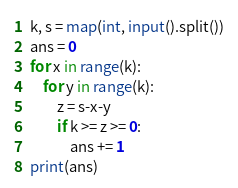<code> <loc_0><loc_0><loc_500><loc_500><_Python_>k, s = map(int, input().split())
ans = 0
for x in range(k):
    for y in range(k):
        z = s-x-y
        if k >= z >= 0:
            ans += 1
print(ans)</code> 